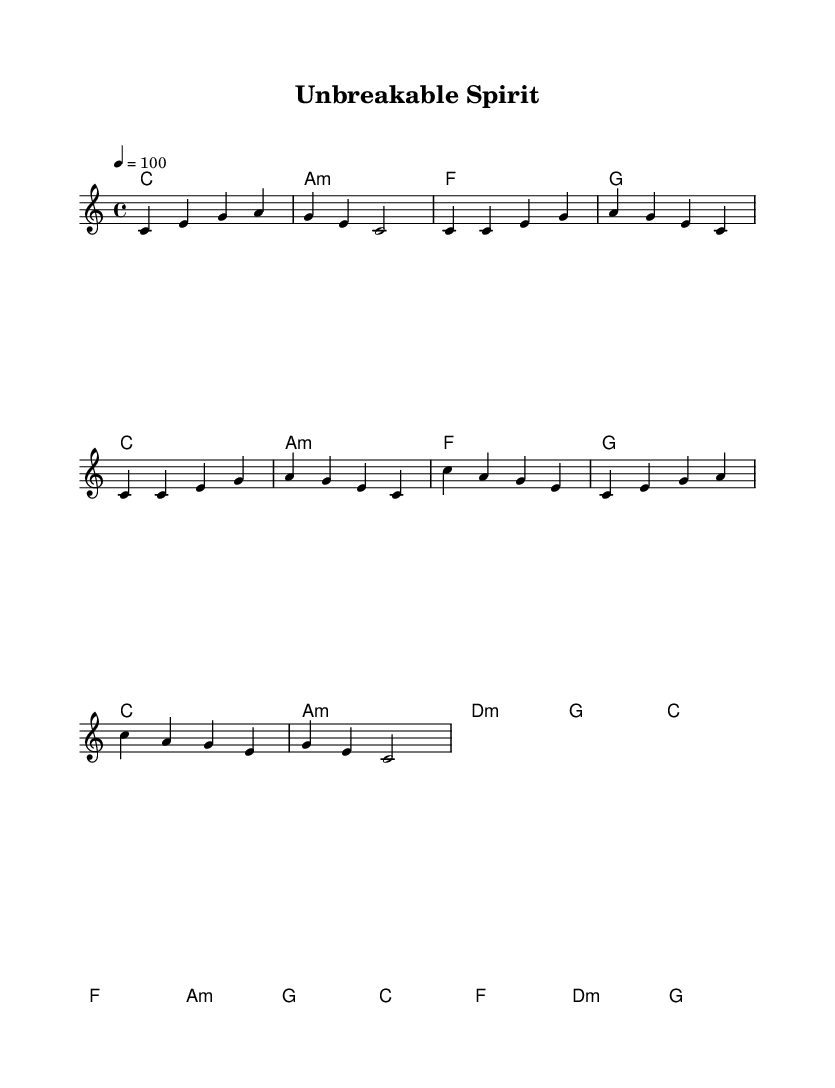What is the key signature of this music? The key signature is C major, which is indicated by the absence of any sharps or flats on the staff.
Answer: C major What is the time signature of the piece? The time signature of the piece is found at the beginning of the score, indicated as 4/4, which means there are four beats in each measure.
Answer: 4/4 What is the tempo marking for this piece? The tempo marking is indicated by the number 100, representing the number of quarter note beats per minute, which guides the speed of the performance.
Answer: 100 How many measures are in the intro section? The intro section has one measure, as indicated by the single bar line that concludes the notes for that section.
Answer: 1 What is the first note of the chorus? The first note of the chorus is the note C, as shown in the melody part at the beginning of that section on the staff.
Answer: C What harmony chord is used in the first measure? The harmony chord used in the first measure is C major, which is indicated by the chord name written directly above the staff.
Answer: C How many different chords are used in the chorus? The chorus section uses four different chords: C major, F major, A minor, and G major, which are distinguished by their unique chord symbols appearing above the music.
Answer: 4 